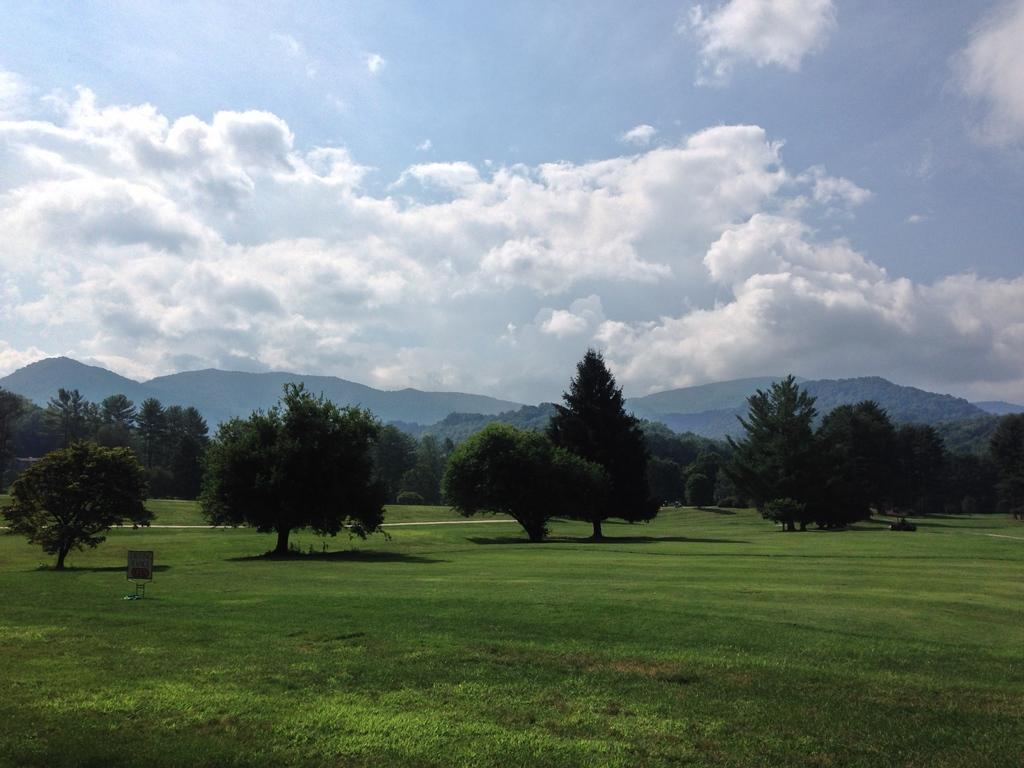What type of vegetation is present on the ground in the image? There is grass on the ground in the image. What can be seen in the image besides the grass? There is an object, trees, mountains, and clouds in the sky in the image. What type of natural features are visible in the image? Trees and mountains are visible in the image. What is visible in the sky in the image? Clouds are visible in the sky in the image. What type of punishment is being enforced by the society in the image? There is no indication of any punishment or society in the image; it features grass, an object, trees, mountains, and clouds. 